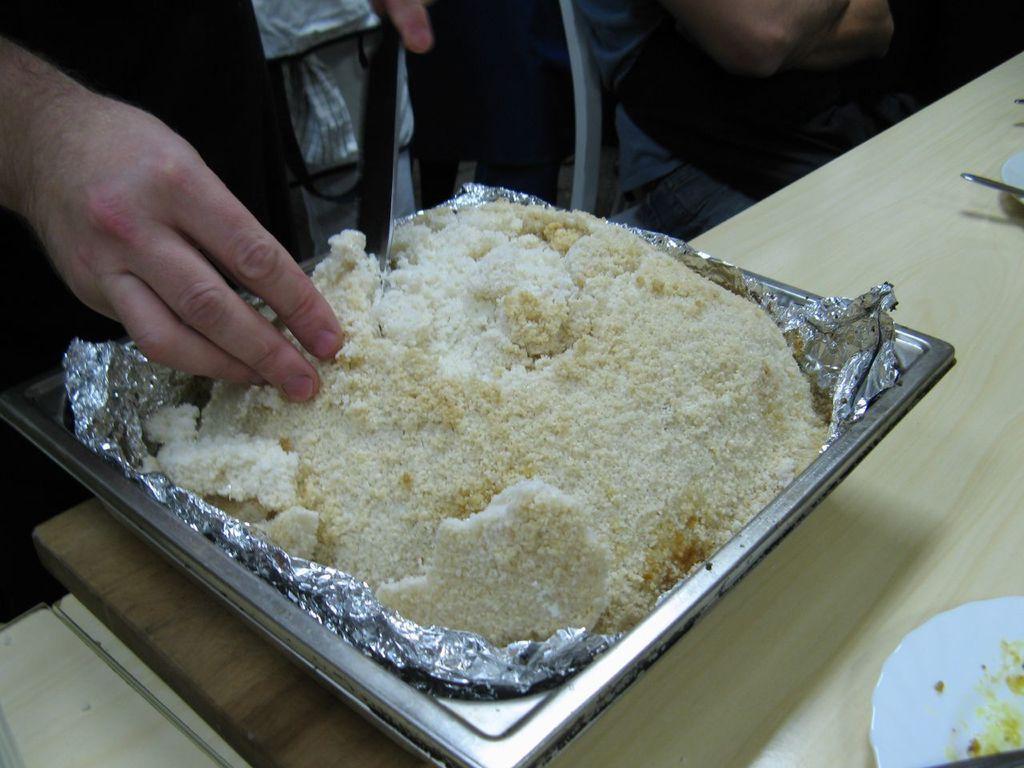How would you summarize this image in a sentence or two? At the bottom of the image we can see a table, on the table we can see some plates, spoons and bowl. In the bowl we can see some food. At the top of the image a person is sitting and two persons are standing and holding something in the hand. 